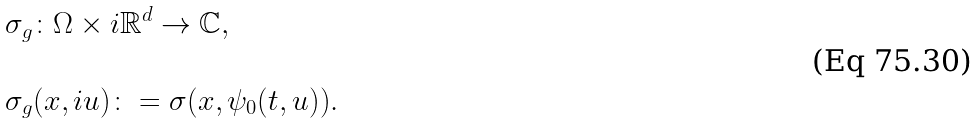<formula> <loc_0><loc_0><loc_500><loc_500>& \sigma _ { g } \colon \Omega \times i { \mathbb { R } } ^ { d } \rightarrow { \mathbb { C } } , \\ \\ & \sigma _ { g } ( x , i u ) \colon = \sigma ( x , \psi _ { 0 } ( t , u ) ) .</formula> 